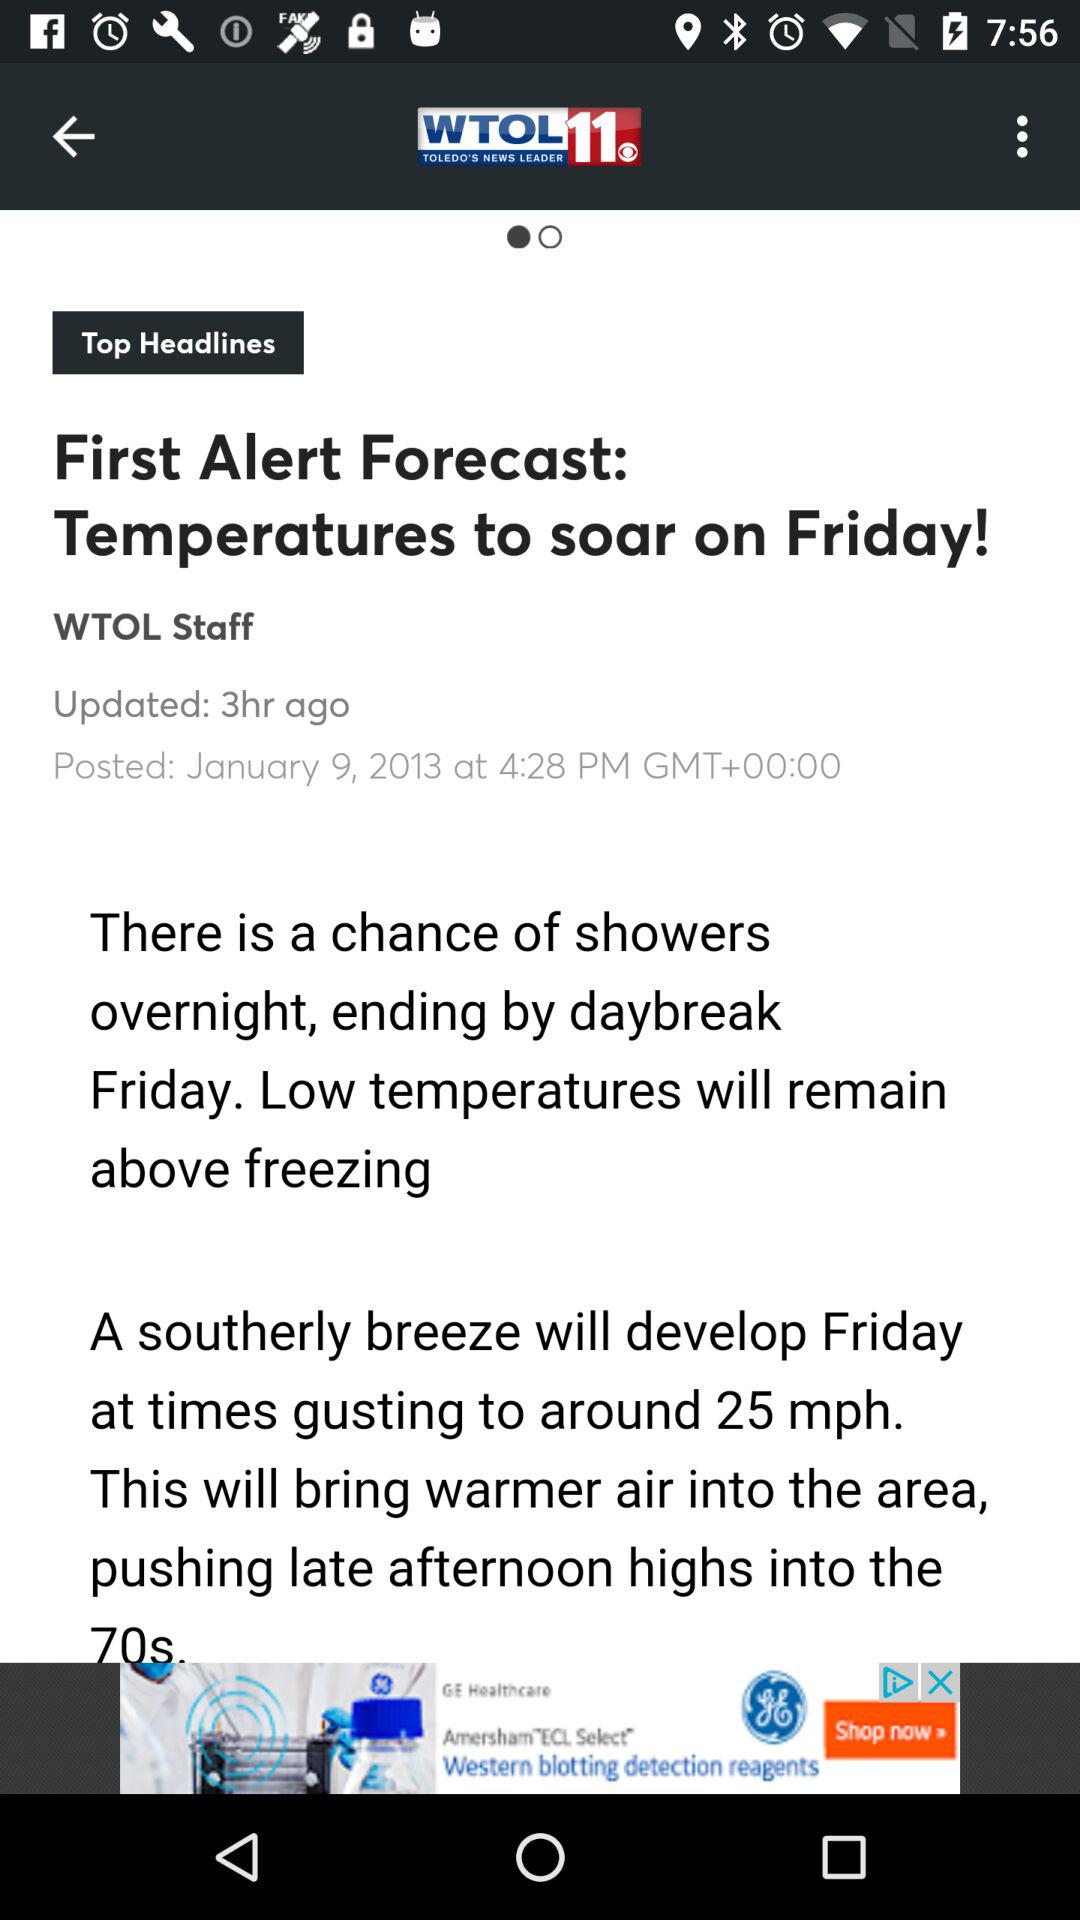What is the name of the application? The name of the application is "WTOL 11 TOLEDO'S NEWS LEADER". 